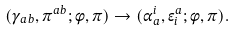<formula> <loc_0><loc_0><loc_500><loc_500>( \gamma _ { a b } , \pi ^ { a b } ; \phi , \pi ) \rightarrow ( { \alpha } ^ { i } _ { a } , { \epsilon } ^ { a } _ { i } ; \phi , \pi ) .</formula> 